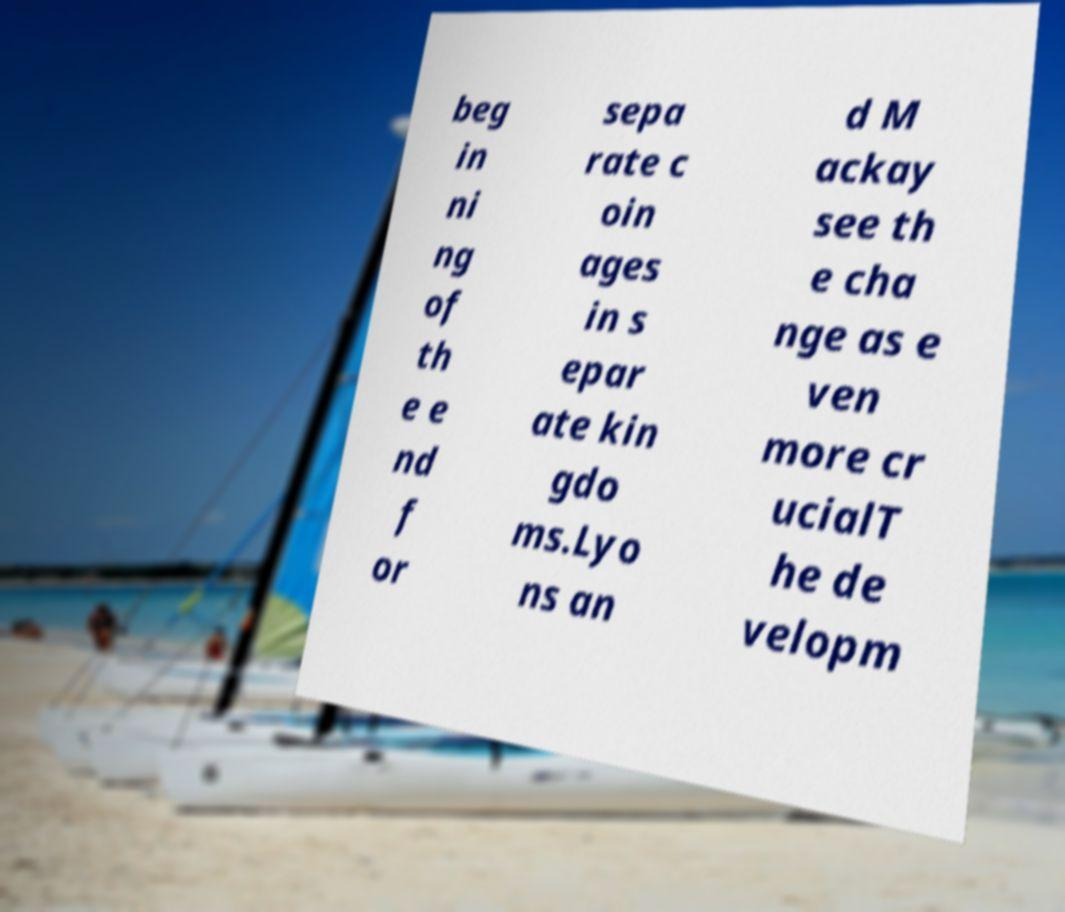Could you extract and type out the text from this image? beg in ni ng of th e e nd f or sepa rate c oin ages in s epar ate kin gdo ms.Lyo ns an d M ackay see th e cha nge as e ven more cr ucialT he de velopm 